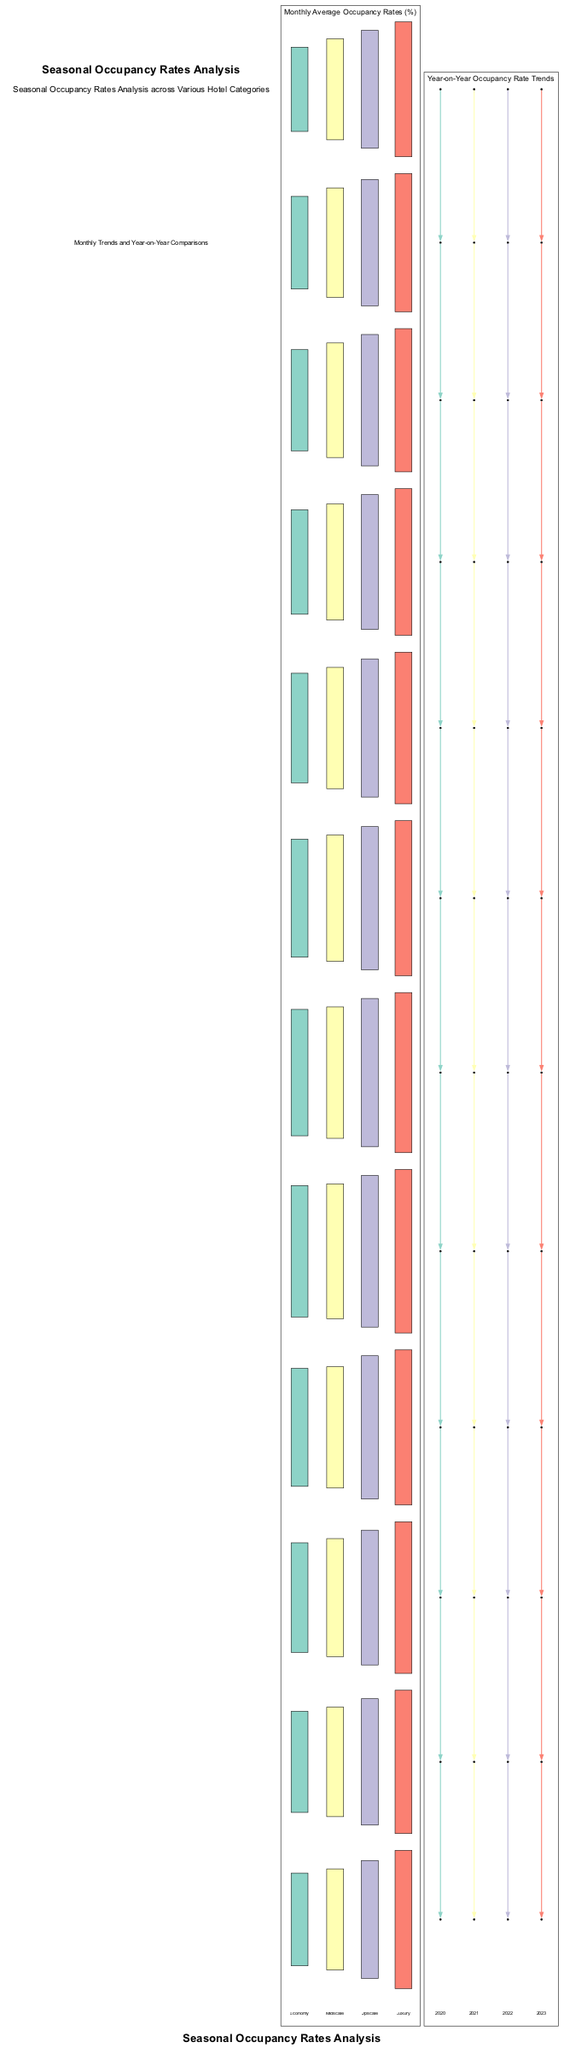What is the average occupancy rate for Luxury hotels in July? By examining the bar chart labeled "Monthly Average Occupancy Rates (%)", I locate the category "Luxury". In the month of July, the value represented in the diagram is 95.
Answer: 95 How many hotel categories are represented in the bar chart? The bar chart displays data for four distinct categories: Economy, Midscale, Upscale, and Luxury. Therefore, the total count of categories is four.
Answer: 4 Which month experienced the highest average occupancy rate for Upscale hotels? Reviewing the bar chart under the category "Upscale", the month of August holds the highest average occupancy rate at 90%, compared to other months.
Answer: 90 What was the occupancy rate for all categories in March 2022? To determine this, I check the line chart labeled "Year-on-Year Occupancy Rate Trends" for the year 2022 and locate the month of March. The corresponding value is 67% for that month indicating occupancy for that year.
Answer: 67 In which year did the occupancy rate for Economy hotels decline in December compared to the previous year? The line chart records the data for various years; upon checking the years' values in December, I see that the occupancy rate dropped from 60% in December 2021 to 55% in December 2022. Thus, December 2022 is the year where this decline occurred.
Answer: 2022 Which category had the lowest average occupancy rate in February? A look at the bar chart for the month of February shows the occupancy rates for the different hotel categories. The Economy category at 55% has the lowest rate for that month.
Answer: Economy What trend is observed for Midscale hotels from 2020 to 2023 in June? Analyzing the line chart for Midscale hotels in June across the years, I observe an increase in occupancy rates: 60% in 2020, rising to 70% in 2023. This demonstrates a positive growth trend over the years.
Answer: Increasing How does the average occupancy rate for Luxury hotels in August 2022 compare to that in August 2023? For August in the Luxury category, the rates recorded are 97% in 2022 and 95% in 2023. The comparison shows a decrease of 2% from 2022 to 2023.
Answer: Decreased What is the overall trend of occupancy rates for Midscale hotels from January to December? By reviewing the bar chart for Midscale hotels, I observe a general increasing trend through the months, starting from 60% in January and peaking at 80% in August, followed by a gradual decline until December where it is 60%. Thus, the trend overall is upward with a year-end drop.
Answer: Upward 